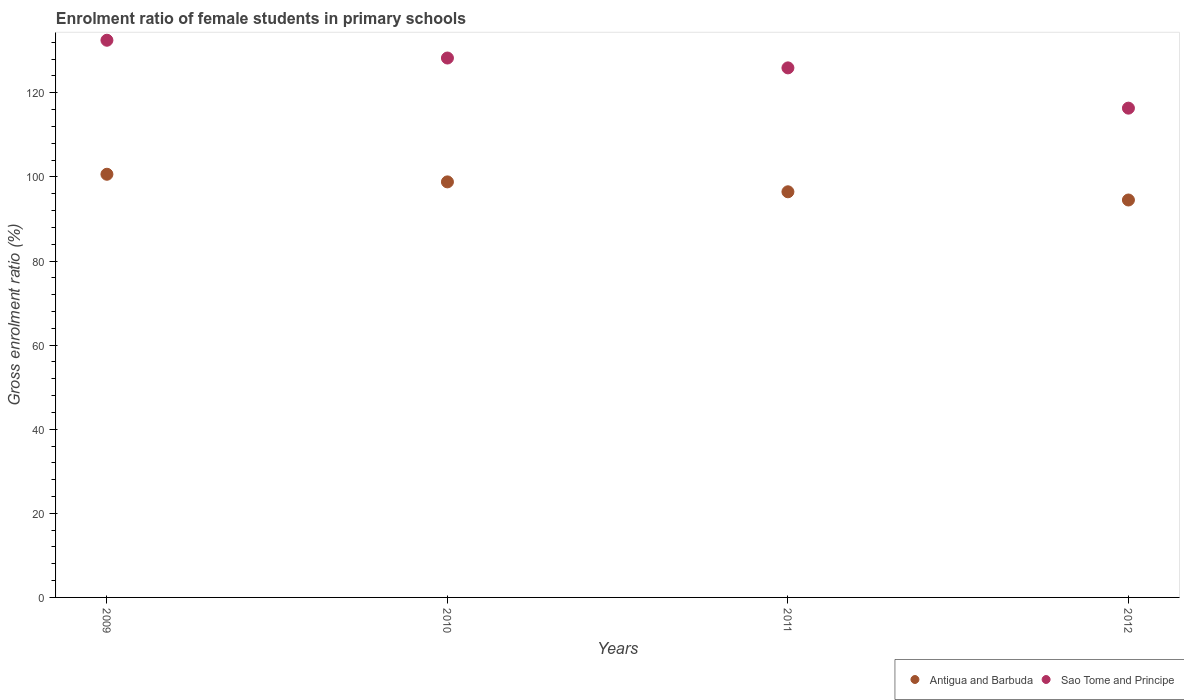How many different coloured dotlines are there?
Offer a terse response. 2. Is the number of dotlines equal to the number of legend labels?
Provide a short and direct response. Yes. What is the enrolment ratio of female students in primary schools in Antigua and Barbuda in 2009?
Ensure brevity in your answer.  100.63. Across all years, what is the maximum enrolment ratio of female students in primary schools in Antigua and Barbuda?
Provide a succinct answer. 100.63. Across all years, what is the minimum enrolment ratio of female students in primary schools in Sao Tome and Principe?
Ensure brevity in your answer.  116.35. What is the total enrolment ratio of female students in primary schools in Antigua and Barbuda in the graph?
Your answer should be compact. 390.41. What is the difference between the enrolment ratio of female students in primary schools in Sao Tome and Principe in 2011 and that in 2012?
Your response must be concise. 9.58. What is the difference between the enrolment ratio of female students in primary schools in Antigua and Barbuda in 2009 and the enrolment ratio of female students in primary schools in Sao Tome and Principe in 2012?
Make the answer very short. -15.72. What is the average enrolment ratio of female students in primary schools in Sao Tome and Principe per year?
Make the answer very short. 125.76. In the year 2010, what is the difference between the enrolment ratio of female students in primary schools in Antigua and Barbuda and enrolment ratio of female students in primary schools in Sao Tome and Principe?
Give a very brief answer. -29.45. In how many years, is the enrolment ratio of female students in primary schools in Sao Tome and Principe greater than 100 %?
Make the answer very short. 4. What is the ratio of the enrolment ratio of female students in primary schools in Sao Tome and Principe in 2009 to that in 2010?
Offer a very short reply. 1.03. What is the difference between the highest and the second highest enrolment ratio of female students in primary schools in Sao Tome and Principe?
Ensure brevity in your answer.  4.23. What is the difference between the highest and the lowest enrolment ratio of female students in primary schools in Antigua and Barbuda?
Make the answer very short. 6.12. In how many years, is the enrolment ratio of female students in primary schools in Antigua and Barbuda greater than the average enrolment ratio of female students in primary schools in Antigua and Barbuda taken over all years?
Make the answer very short. 2. Is the sum of the enrolment ratio of female students in primary schools in Antigua and Barbuda in 2010 and 2012 greater than the maximum enrolment ratio of female students in primary schools in Sao Tome and Principe across all years?
Your answer should be very brief. Yes. How many dotlines are there?
Provide a short and direct response. 2. How many years are there in the graph?
Provide a short and direct response. 4. Are the values on the major ticks of Y-axis written in scientific E-notation?
Provide a succinct answer. No. Where does the legend appear in the graph?
Your answer should be very brief. Bottom right. How many legend labels are there?
Keep it short and to the point. 2. What is the title of the graph?
Ensure brevity in your answer.  Enrolment ratio of female students in primary schools. Does "Kosovo" appear as one of the legend labels in the graph?
Provide a succinct answer. No. What is the label or title of the Y-axis?
Give a very brief answer. Gross enrolment ratio (%). What is the Gross enrolment ratio (%) in Antigua and Barbuda in 2009?
Ensure brevity in your answer.  100.63. What is the Gross enrolment ratio (%) in Sao Tome and Principe in 2009?
Keep it short and to the point. 132.5. What is the Gross enrolment ratio (%) of Antigua and Barbuda in 2010?
Your answer should be compact. 98.81. What is the Gross enrolment ratio (%) in Sao Tome and Principe in 2010?
Give a very brief answer. 128.27. What is the Gross enrolment ratio (%) of Antigua and Barbuda in 2011?
Ensure brevity in your answer.  96.46. What is the Gross enrolment ratio (%) in Sao Tome and Principe in 2011?
Offer a very short reply. 125.92. What is the Gross enrolment ratio (%) of Antigua and Barbuda in 2012?
Your answer should be very brief. 94.51. What is the Gross enrolment ratio (%) of Sao Tome and Principe in 2012?
Keep it short and to the point. 116.35. Across all years, what is the maximum Gross enrolment ratio (%) of Antigua and Barbuda?
Provide a short and direct response. 100.63. Across all years, what is the maximum Gross enrolment ratio (%) of Sao Tome and Principe?
Make the answer very short. 132.5. Across all years, what is the minimum Gross enrolment ratio (%) of Antigua and Barbuda?
Offer a very short reply. 94.51. Across all years, what is the minimum Gross enrolment ratio (%) in Sao Tome and Principe?
Keep it short and to the point. 116.35. What is the total Gross enrolment ratio (%) in Antigua and Barbuda in the graph?
Offer a very short reply. 390.41. What is the total Gross enrolment ratio (%) of Sao Tome and Principe in the graph?
Your response must be concise. 503.03. What is the difference between the Gross enrolment ratio (%) in Antigua and Barbuda in 2009 and that in 2010?
Offer a terse response. 1.81. What is the difference between the Gross enrolment ratio (%) in Sao Tome and Principe in 2009 and that in 2010?
Your response must be concise. 4.23. What is the difference between the Gross enrolment ratio (%) of Antigua and Barbuda in 2009 and that in 2011?
Offer a terse response. 4.17. What is the difference between the Gross enrolment ratio (%) in Sao Tome and Principe in 2009 and that in 2011?
Offer a terse response. 6.57. What is the difference between the Gross enrolment ratio (%) of Antigua and Barbuda in 2009 and that in 2012?
Your answer should be very brief. 6.12. What is the difference between the Gross enrolment ratio (%) in Sao Tome and Principe in 2009 and that in 2012?
Offer a terse response. 16.15. What is the difference between the Gross enrolment ratio (%) in Antigua and Barbuda in 2010 and that in 2011?
Ensure brevity in your answer.  2.35. What is the difference between the Gross enrolment ratio (%) in Sao Tome and Principe in 2010 and that in 2011?
Keep it short and to the point. 2.34. What is the difference between the Gross enrolment ratio (%) of Antigua and Barbuda in 2010 and that in 2012?
Provide a succinct answer. 4.31. What is the difference between the Gross enrolment ratio (%) in Sao Tome and Principe in 2010 and that in 2012?
Offer a terse response. 11.92. What is the difference between the Gross enrolment ratio (%) in Antigua and Barbuda in 2011 and that in 2012?
Your response must be concise. 1.95. What is the difference between the Gross enrolment ratio (%) of Sao Tome and Principe in 2011 and that in 2012?
Your answer should be compact. 9.58. What is the difference between the Gross enrolment ratio (%) of Antigua and Barbuda in 2009 and the Gross enrolment ratio (%) of Sao Tome and Principe in 2010?
Your answer should be very brief. -27.64. What is the difference between the Gross enrolment ratio (%) of Antigua and Barbuda in 2009 and the Gross enrolment ratio (%) of Sao Tome and Principe in 2011?
Offer a terse response. -25.3. What is the difference between the Gross enrolment ratio (%) in Antigua and Barbuda in 2009 and the Gross enrolment ratio (%) in Sao Tome and Principe in 2012?
Give a very brief answer. -15.72. What is the difference between the Gross enrolment ratio (%) of Antigua and Barbuda in 2010 and the Gross enrolment ratio (%) of Sao Tome and Principe in 2011?
Give a very brief answer. -27.11. What is the difference between the Gross enrolment ratio (%) of Antigua and Barbuda in 2010 and the Gross enrolment ratio (%) of Sao Tome and Principe in 2012?
Offer a very short reply. -17.53. What is the difference between the Gross enrolment ratio (%) of Antigua and Barbuda in 2011 and the Gross enrolment ratio (%) of Sao Tome and Principe in 2012?
Offer a very short reply. -19.89. What is the average Gross enrolment ratio (%) of Antigua and Barbuda per year?
Provide a short and direct response. 97.6. What is the average Gross enrolment ratio (%) in Sao Tome and Principe per year?
Ensure brevity in your answer.  125.76. In the year 2009, what is the difference between the Gross enrolment ratio (%) in Antigua and Barbuda and Gross enrolment ratio (%) in Sao Tome and Principe?
Provide a succinct answer. -31.87. In the year 2010, what is the difference between the Gross enrolment ratio (%) of Antigua and Barbuda and Gross enrolment ratio (%) of Sao Tome and Principe?
Offer a terse response. -29.45. In the year 2011, what is the difference between the Gross enrolment ratio (%) in Antigua and Barbuda and Gross enrolment ratio (%) in Sao Tome and Principe?
Offer a terse response. -29.47. In the year 2012, what is the difference between the Gross enrolment ratio (%) in Antigua and Barbuda and Gross enrolment ratio (%) in Sao Tome and Principe?
Your answer should be very brief. -21.84. What is the ratio of the Gross enrolment ratio (%) in Antigua and Barbuda in 2009 to that in 2010?
Provide a succinct answer. 1.02. What is the ratio of the Gross enrolment ratio (%) of Sao Tome and Principe in 2009 to that in 2010?
Provide a short and direct response. 1.03. What is the ratio of the Gross enrolment ratio (%) of Antigua and Barbuda in 2009 to that in 2011?
Make the answer very short. 1.04. What is the ratio of the Gross enrolment ratio (%) in Sao Tome and Principe in 2009 to that in 2011?
Offer a very short reply. 1.05. What is the ratio of the Gross enrolment ratio (%) of Antigua and Barbuda in 2009 to that in 2012?
Your answer should be compact. 1.06. What is the ratio of the Gross enrolment ratio (%) in Sao Tome and Principe in 2009 to that in 2012?
Your response must be concise. 1.14. What is the ratio of the Gross enrolment ratio (%) in Antigua and Barbuda in 2010 to that in 2011?
Your response must be concise. 1.02. What is the ratio of the Gross enrolment ratio (%) of Sao Tome and Principe in 2010 to that in 2011?
Provide a short and direct response. 1.02. What is the ratio of the Gross enrolment ratio (%) of Antigua and Barbuda in 2010 to that in 2012?
Offer a terse response. 1.05. What is the ratio of the Gross enrolment ratio (%) in Sao Tome and Principe in 2010 to that in 2012?
Ensure brevity in your answer.  1.1. What is the ratio of the Gross enrolment ratio (%) of Antigua and Barbuda in 2011 to that in 2012?
Provide a short and direct response. 1.02. What is the ratio of the Gross enrolment ratio (%) of Sao Tome and Principe in 2011 to that in 2012?
Your response must be concise. 1.08. What is the difference between the highest and the second highest Gross enrolment ratio (%) in Antigua and Barbuda?
Your answer should be very brief. 1.81. What is the difference between the highest and the second highest Gross enrolment ratio (%) of Sao Tome and Principe?
Ensure brevity in your answer.  4.23. What is the difference between the highest and the lowest Gross enrolment ratio (%) of Antigua and Barbuda?
Give a very brief answer. 6.12. What is the difference between the highest and the lowest Gross enrolment ratio (%) of Sao Tome and Principe?
Your answer should be very brief. 16.15. 